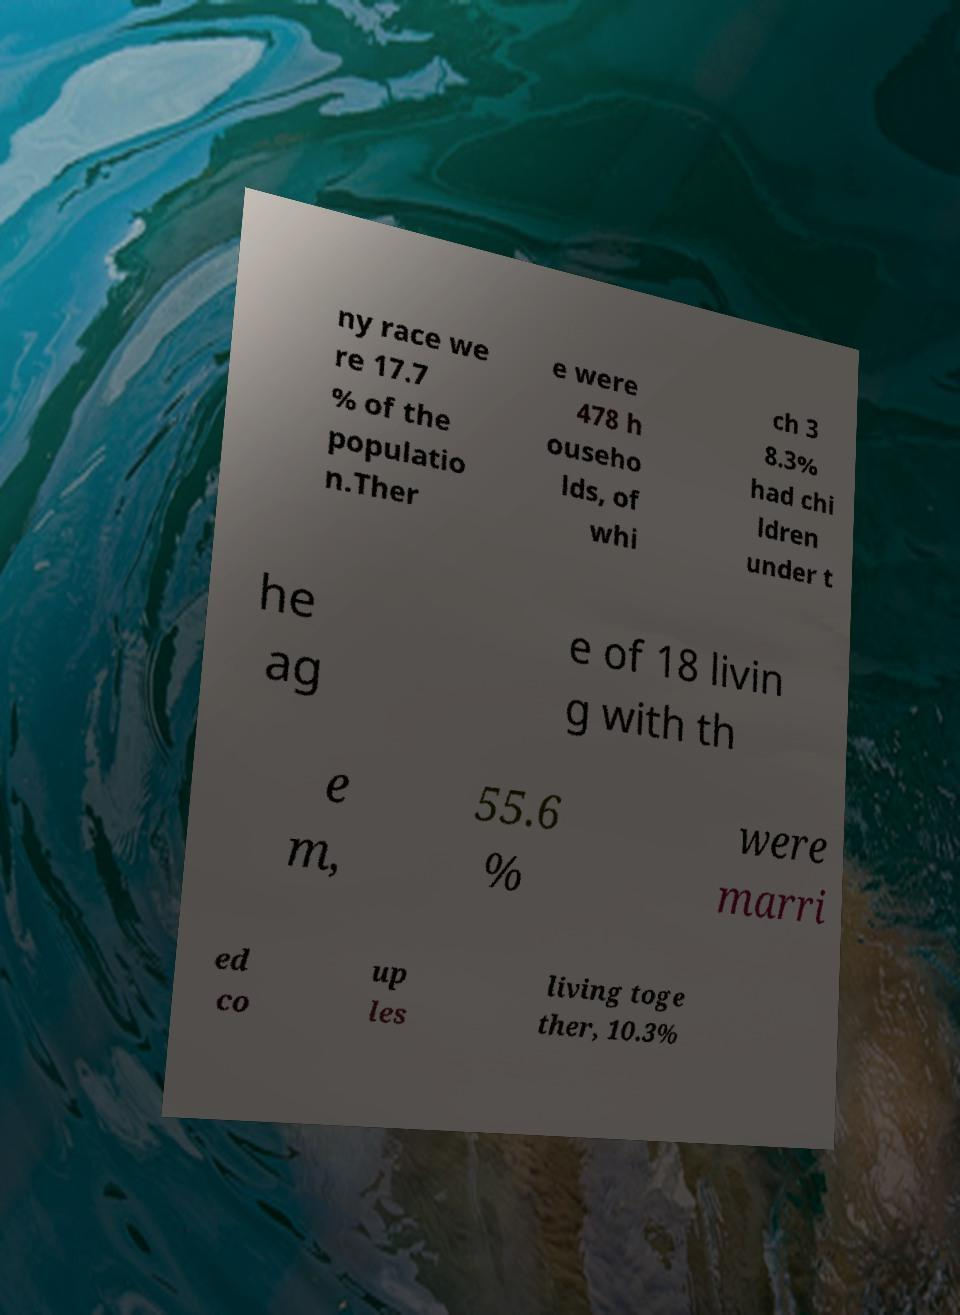Could you assist in decoding the text presented in this image and type it out clearly? ny race we re 17.7 % of the populatio n.Ther e were 478 h ouseho lds, of whi ch 3 8.3% had chi ldren under t he ag e of 18 livin g with th e m, 55.6 % were marri ed co up les living toge ther, 10.3% 